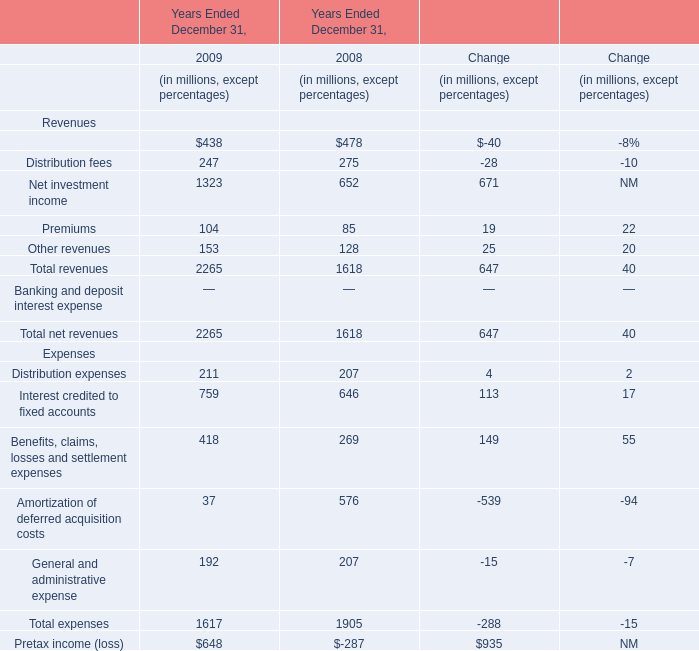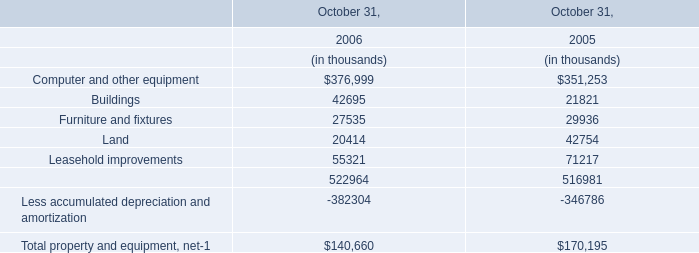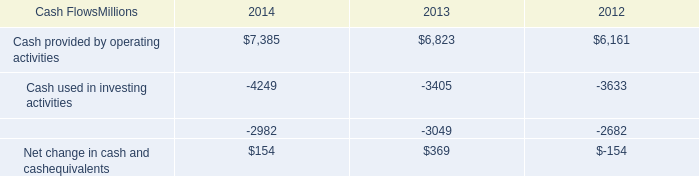What's the current growth rate of Interest credited to fixed accounts ? 
Computations: ((759 - 646) / 646)
Answer: 0.17492. 